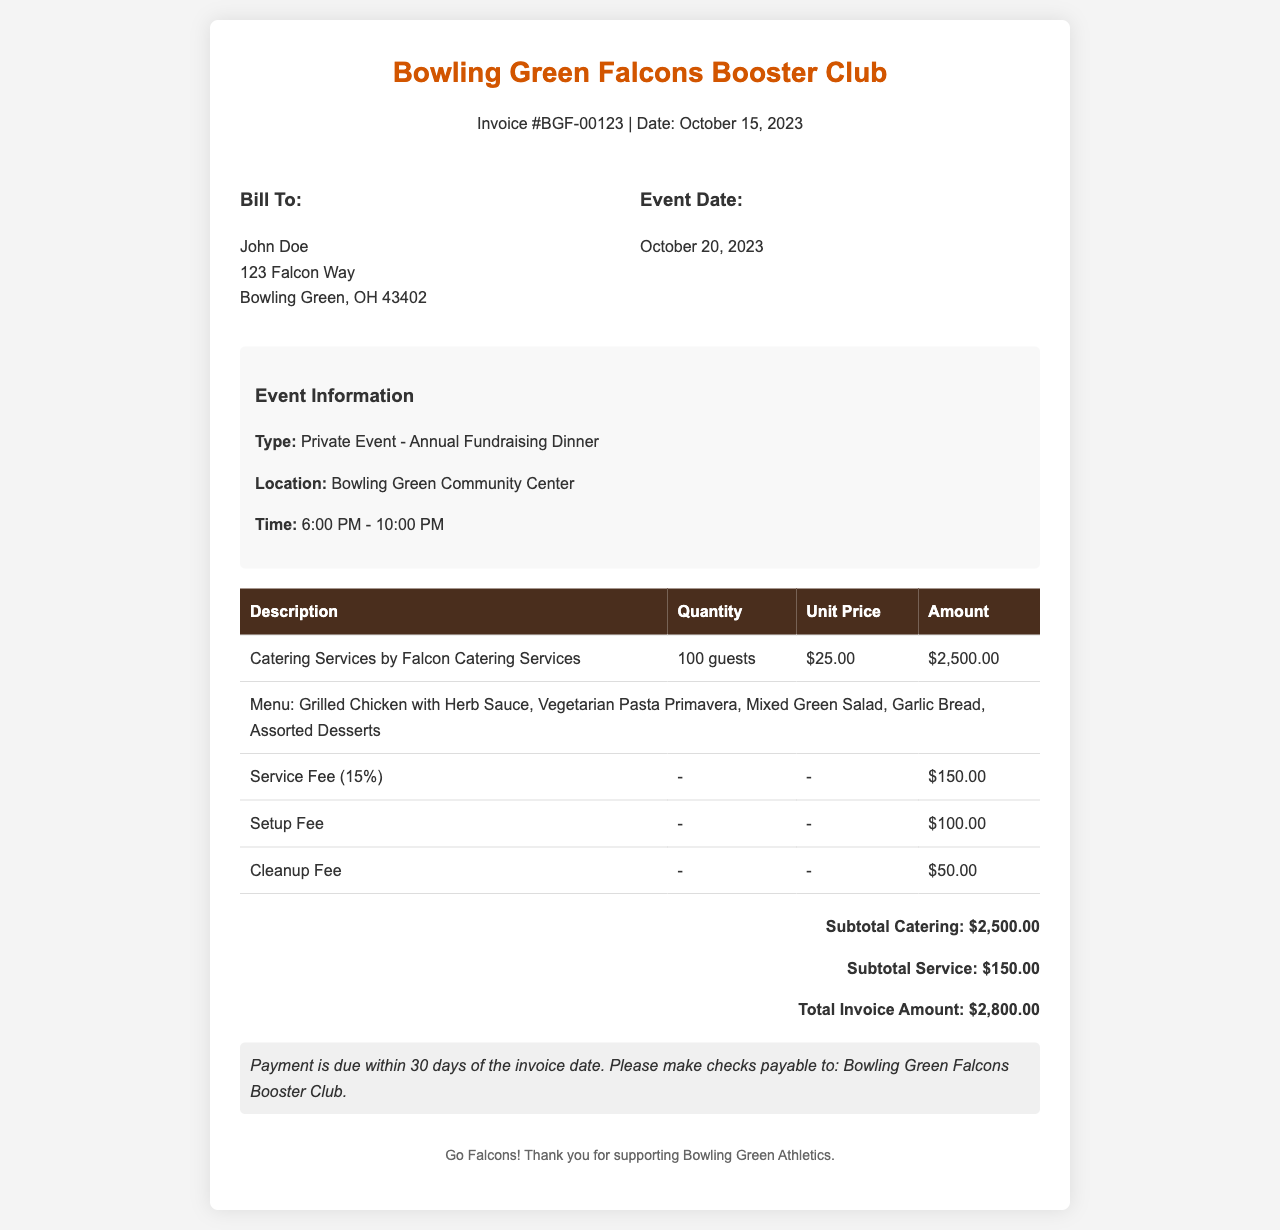What is the invoice number? The invoice number is specified in the document for tracking purposes, which is listed as BGF-00123.
Answer: BGF-00123 What was the event date? The date of the event is explicitly mentioned in the document, which is October 20, 2023.
Answer: October 20, 2023 Who is the invoice billed to? The document provides the name of the individual or entity being billed, which is John Doe.
Answer: John Doe What is the subtotal for catering services? The subtotal for catering is provided in the totals section, which states $2,500.00.
Answer: $2,500.00 What is the service fee percentage? The document mentions a service fee of 15%, which is applied to the catering services.
Answer: 15% Which location is the event held at? The event location is specified in the document as Bowling Green Community Center.
Answer: Bowling Green Community Center What is the total invoice amount? The total amount due is calculated by summing the subtotals, as detailed in the document, which is $2,800.00.
Answer: $2,800.00 What type of event is described in the invoice? The document classifies the event type, which is a Private Event - Annual Fundraising Dinner.
Answer: Private Event - Annual Fundraising Dinner When is payment due? The payment terms indicate a specific time frame, stating that payment is due within 30 days of the invoice date.
Answer: 30 days 